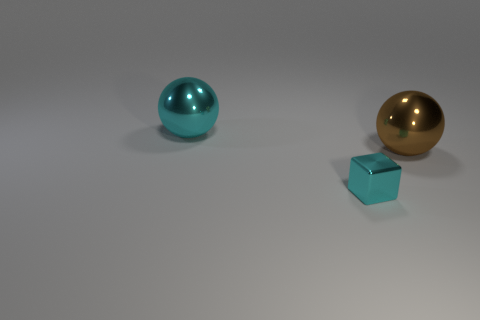There is a sphere that is the same size as the brown shiny object; what is it made of?
Ensure brevity in your answer.  Metal. Is there a big shiny sphere that has the same color as the tiny metallic cube?
Your answer should be very brief. Yes. What is the shape of the shiny thing that is both in front of the large cyan shiny thing and behind the tiny object?
Ensure brevity in your answer.  Sphere. How many cyan objects have the same material as the block?
Provide a succinct answer. 1. Are there fewer tiny blocks left of the large brown ball than things behind the tiny metallic cube?
Provide a short and direct response. Yes. What material is the ball in front of the ball behind the big metal ball in front of the cyan shiny sphere made of?
Ensure brevity in your answer.  Metal. What is the size of the thing that is in front of the big cyan ball and on the left side of the large brown object?
Your answer should be very brief. Small. What number of spheres are either large cyan metal objects or cyan metal things?
Your answer should be very brief. 1. The other object that is the same size as the brown shiny thing is what color?
Offer a terse response. Cyan. Are there any other things that have the same shape as the large cyan metal object?
Provide a short and direct response. Yes. 